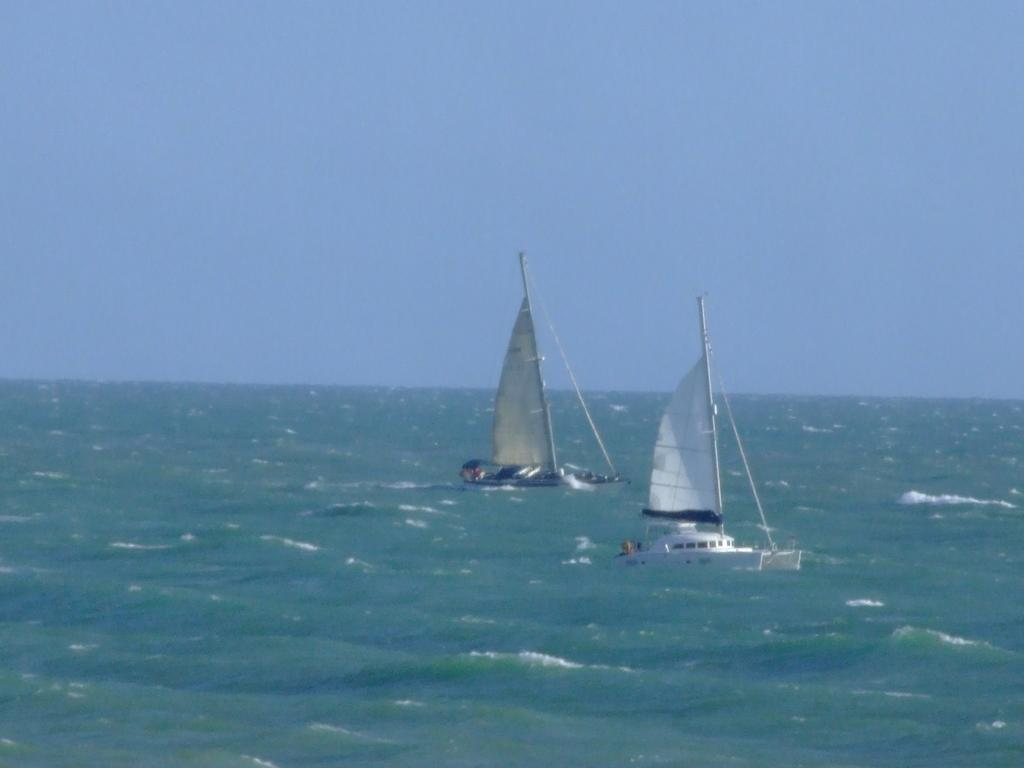What type of body of water is present in the image? There is an ocean in the image. What can be seen floating on the ocean? There are two boats visible in the ocean. What is visible above the ocean in the image? The sky is visible at the top of the image. What type of statement can be seen written on the side of the boats? There is no statement visible on the boats in the image. How many tickets are needed to board the boats in the image? There is no information about tickets in the image, as it only shows the boats and the ocean. 